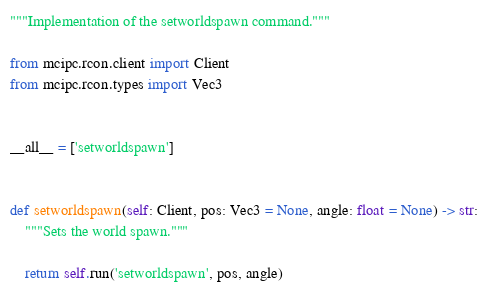Convert code to text. <code><loc_0><loc_0><loc_500><loc_500><_Python_>"""Implementation of the setworldspawn command."""

from mcipc.rcon.client import Client
from mcipc.rcon.types import Vec3


__all__ = ['setworldspawn']


def setworldspawn(self: Client, pos: Vec3 = None, angle: float = None) -> str:
    """Sets the world spawn."""

    return self.run('setworldspawn', pos, angle)
</code> 